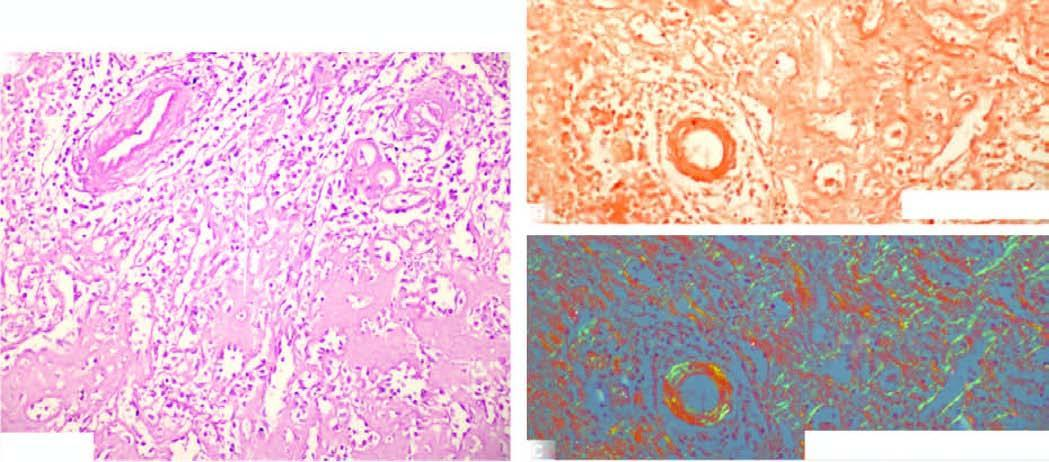does the corresponding area show apple-green birefringence?
Answer the question using a single word or phrase. Yes 